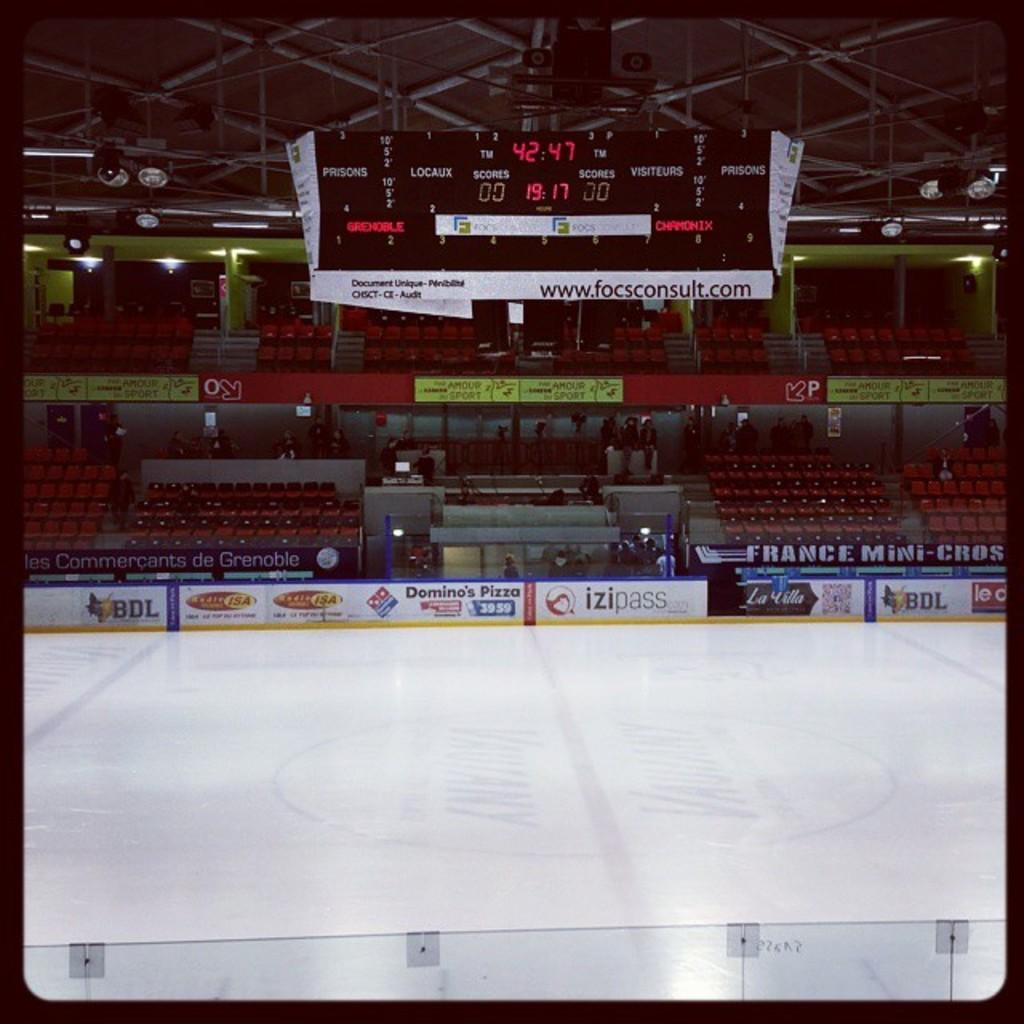<image>
Summarize the visual content of the image. AN ice hockey rick has several banners including one for Domino's Pizza. 